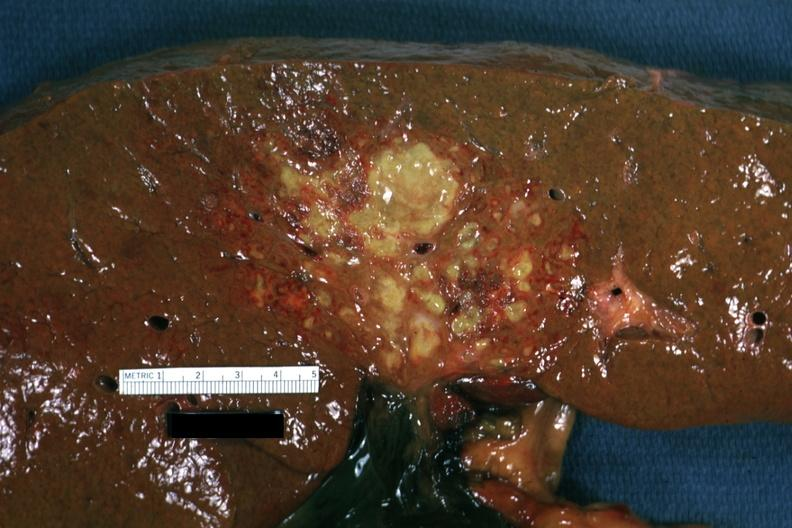what looks like an ascending cholangitis?
Answer the question using a single word or phrase. This 